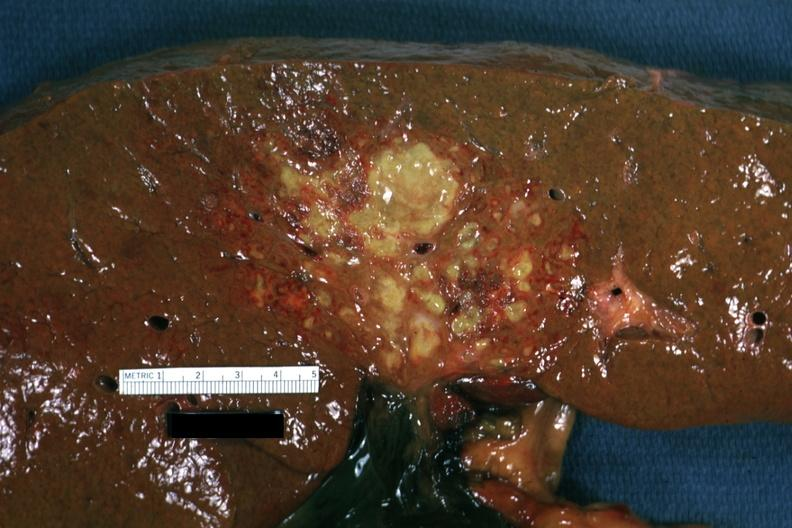what looks like an ascending cholangitis?
Answer the question using a single word or phrase. This 